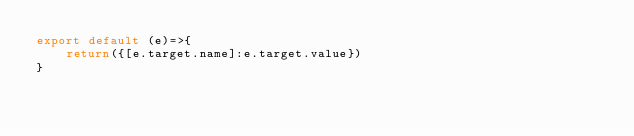<code> <loc_0><loc_0><loc_500><loc_500><_JavaScript_>export default (e)=>{
    return({[e.target.name]:e.target.value})
}</code> 